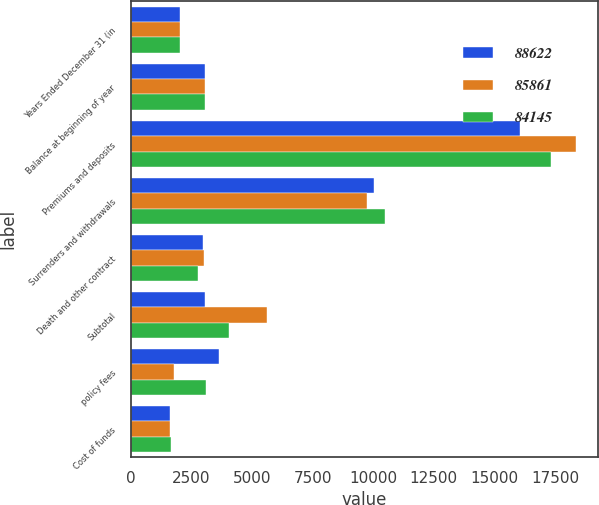<chart> <loc_0><loc_0><loc_500><loc_500><stacked_bar_chart><ecel><fcel>Years Ended December 31 (in<fcel>Balance at beginning of year<fcel>Premiums and deposits<fcel>Surrenders and withdrawals<fcel>Death and other contract<fcel>Subtotal<fcel>policy fees<fcel>Cost of funds<nl><fcel>88622<fcel>2016<fcel>3044<fcel>16062<fcel>10027<fcel>2991<fcel>3044<fcel>3657<fcel>1614<nl><fcel>85861<fcel>2015<fcel>3044<fcel>18376<fcel>9742<fcel>3016<fcel>5618<fcel>1775<fcel>1613<nl><fcel>84145<fcel>2014<fcel>3044<fcel>17324<fcel>10500<fcel>2792<fcel>4032<fcel>3086<fcel>1644<nl></chart> 